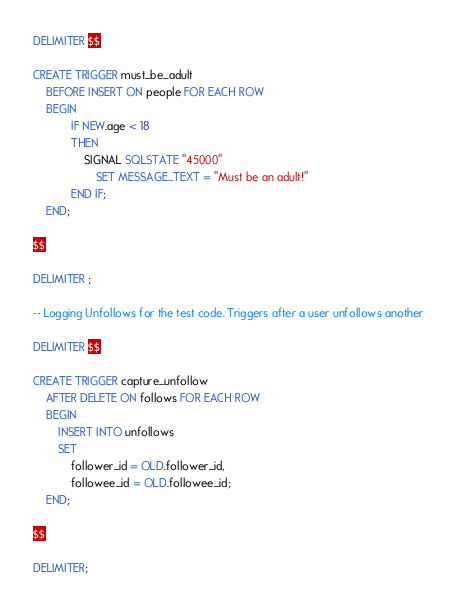Convert code to text. <code><loc_0><loc_0><loc_500><loc_500><_SQL_>DELIMITER $$

CREATE TRIGGER must_be_adult
	BEFORE INSERT ON people FOR EACH ROW
	BEGIN
			IF NEW.age < 18
			THEN
				SIGNAL SQLSTATE "45000"
					SET MESSAGE_TEXT = "Must be an adult!"
			END IF;
	END;

$$

DELIMITER ;

-- Logging Unfollows for the test code. Triggers after a user unfollows another

DELIMITER $$

CREATE TRIGGER capture_unfollow
	AFTER DELETE ON follows FOR EACH ROW
	BEGIN
		INSERT INTO unfollows
		SET
			follower_id = OLD.follower_id,
			followee_id = OLD.followee_id;
	END;

$$

DELIMITER;
</code> 